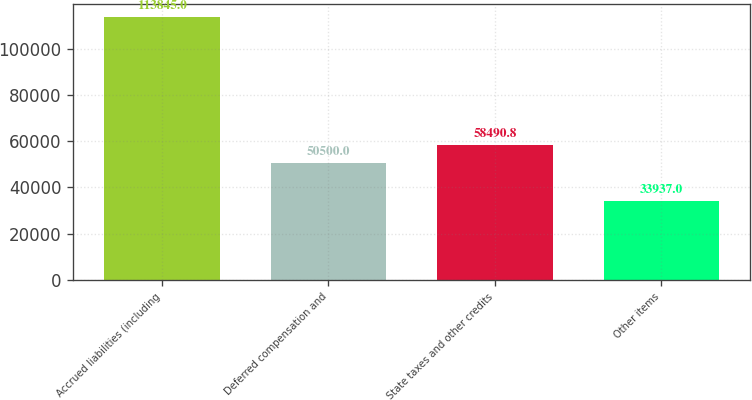Convert chart. <chart><loc_0><loc_0><loc_500><loc_500><bar_chart><fcel>Accrued liabilities (including<fcel>Deferred compensation and<fcel>State taxes and other credits<fcel>Other items<nl><fcel>113845<fcel>50500<fcel>58490.8<fcel>33937<nl></chart> 